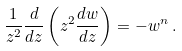Convert formula to latex. <formula><loc_0><loc_0><loc_500><loc_500>\frac { 1 } { z ^ { 2 } } \frac { d } { d z } \left ( z ^ { 2 } \frac { d w } { d z } \right ) = - w ^ { n } \, .</formula> 